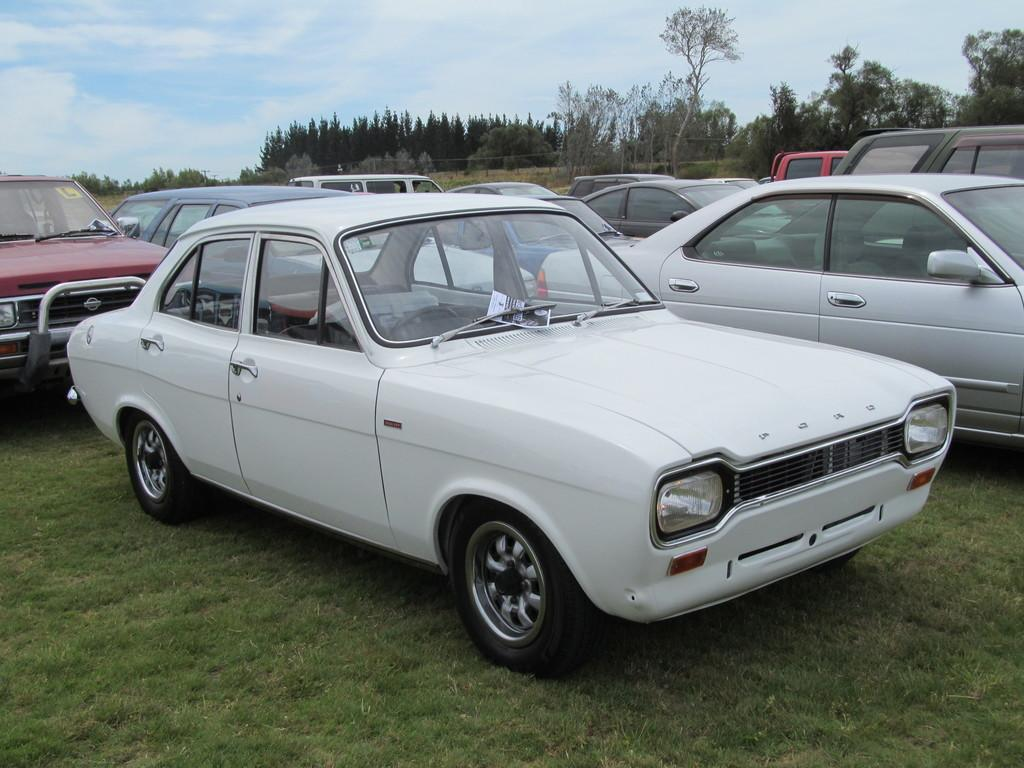What types of objects are on the ground in the image? There are vehicles on the ground in the image. What can be seen in the distance behind the vehicles? There are trees visible in the background of the image. What is visible in the sky at the top of the image? There are clouds in the sky at the top of the image. What type of table is being used to hammer a mass in the image? There is no table, hammer, or mass present in the image. 